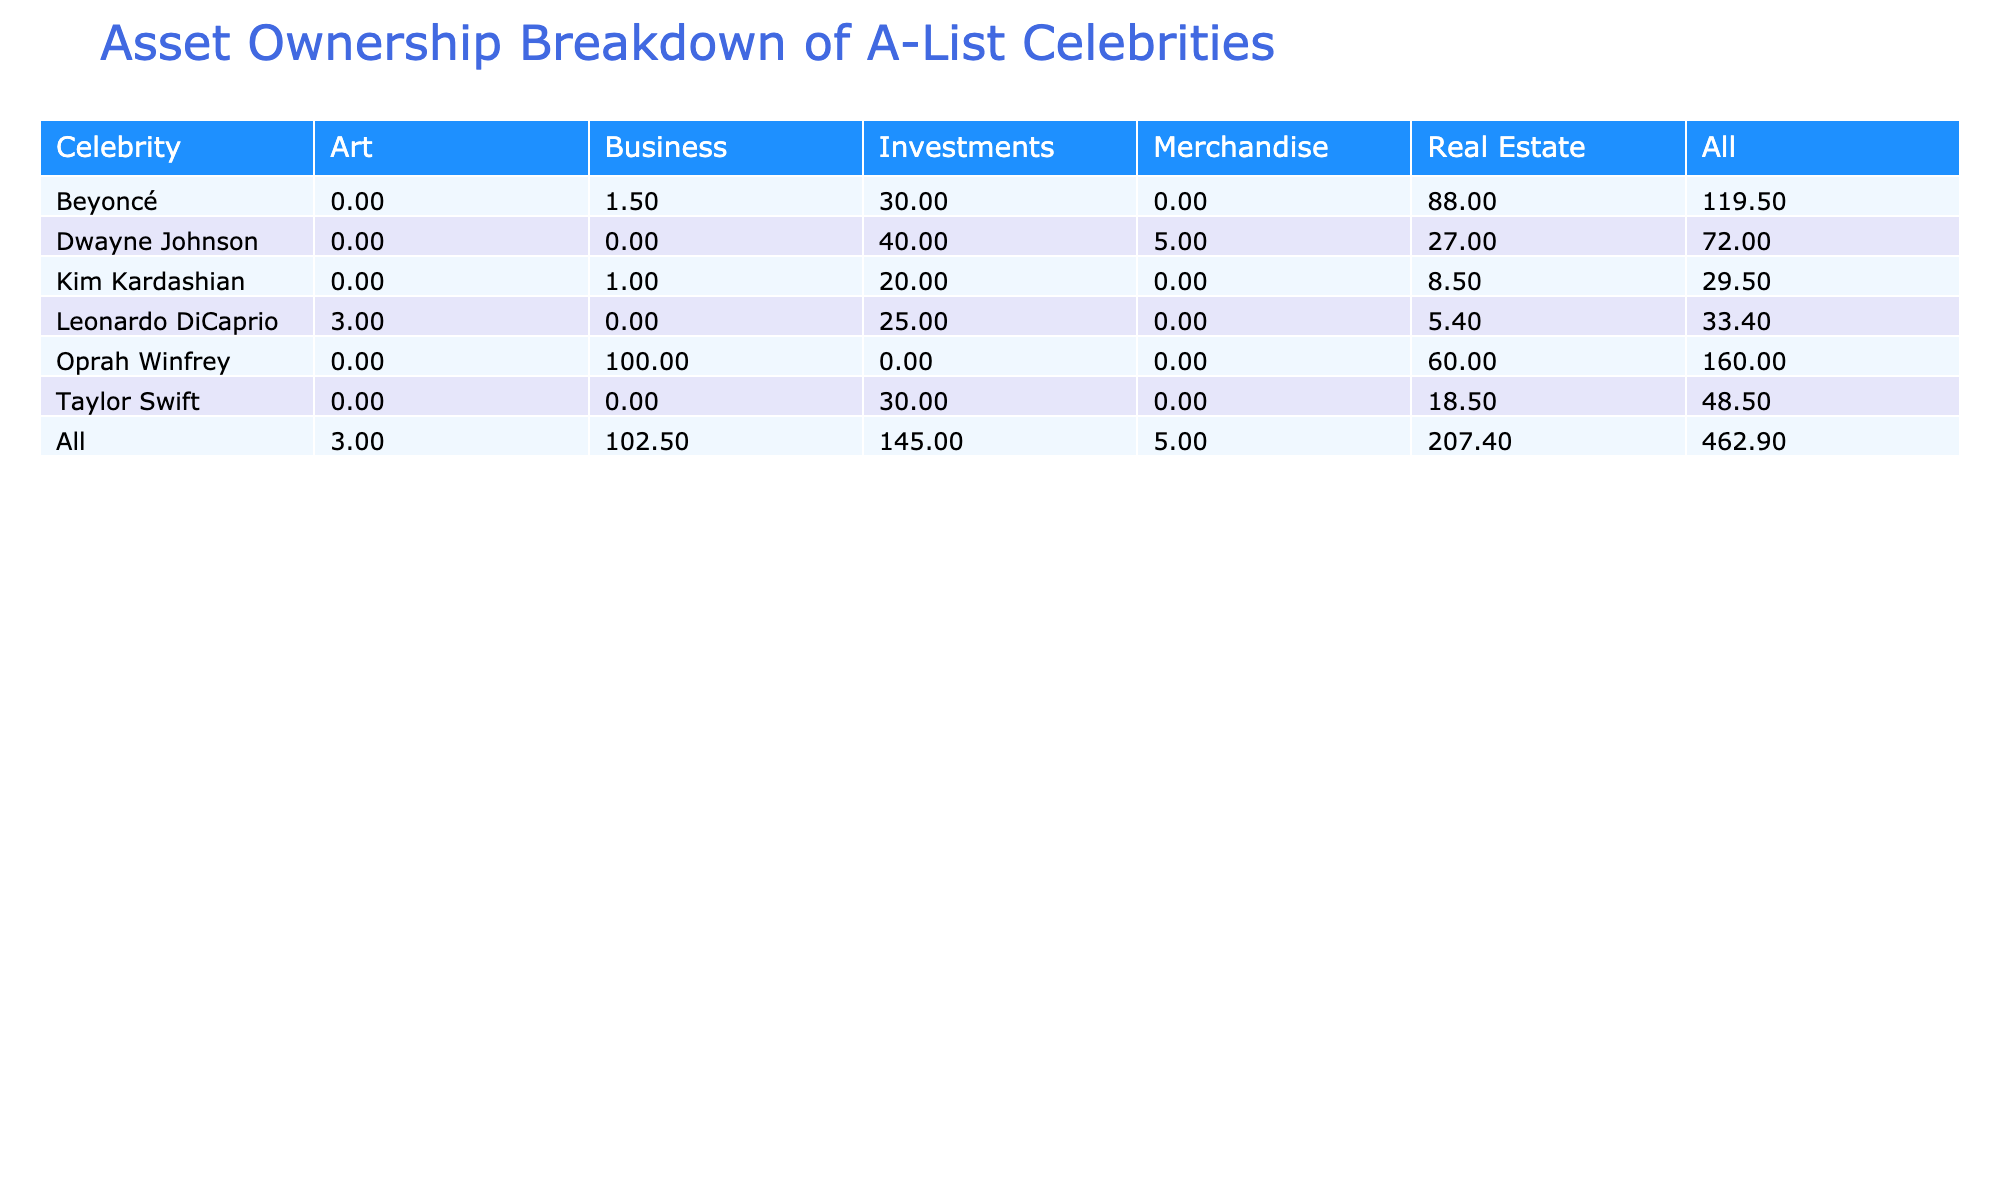What celebrity has the highest estimated value of real estate? Beyoncé's real estate in Los Angeles has an estimated value of 88 million, which is higher than all other entries for real estate.
Answer: Beyoncé What is the total estimated value of Dwayne Johnson's assets? The total estimated value of Dwayne Johnson's assets is calculated by summing his real estate (27 million), investments (40 million), and merchandise (5 million), which equals 72 million.
Answer: 72 million Does Kim Kardashian own more in real estate than in investments? Kim Kardashian’s real estate is valued at 8.5 million, while her investments total 20 million, making her investments more valuable than her real estate.
Answer: No What is the combined value of Oprah Winfrey's real estate holdings? Oprah Winfrey has real estate valued at 10 million in Chicago and 50 million in California, totaling 60 million for her real estate holdings.
Answer: 60 million Which celebrity has the highest total estimated value of investments? Taylor Swift has investments valued at 30 million, Kim Kardashian has investments valued at 20 million, and Dwayne Johnson has investments valued at 40 million; therefore, Dwayne Johnson has the highest total value in investments.
Answer: Dwayne Johnson What is the average estimated value of real estate owned by the celebrities listed? To find the average, sum the values of the real estate owned (3.5 + 15 + 27 + 8.5 + 10 + 50 + 88 + 5.4 = 208.4 million) and divide by the number of real estate holdings (8), resulting in an average of 26.05 million.
Answer: 26.05 million Does Leonardo DiCaprio own more value in art than in real estate? Leonardo DiCaprio's art is valued at 3 million, while his real estate in Los Angeles is valued at 5.4 million, indicating that he owns less in art than in real estate.
Answer: No What is the difference in estimated value between Beyoncé's and Kim Kardashian's total estimated assets? Beyoncé has real estate (88 million), business (1.5 million), and investments (30 million), totaling 119.5 million. Kim Kardashian has real estate (8.5 million), business (1 million), and investments (20 million), totaling 29.5 million. The difference is 119.5 - 29.5 = 90 million.
Answer: 90 million 